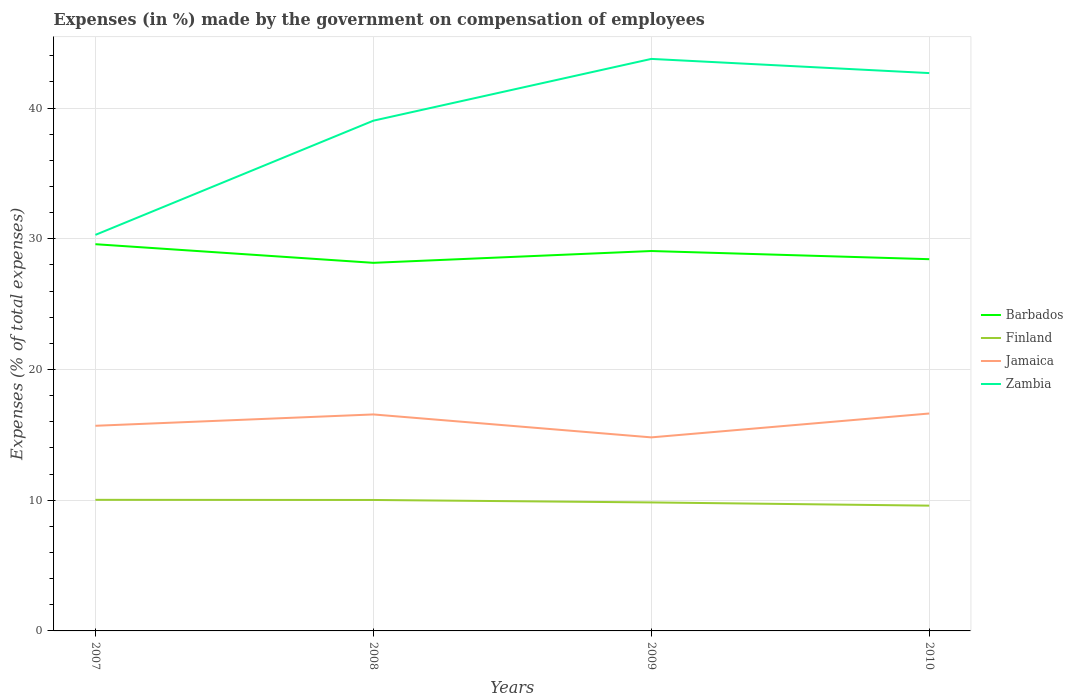Does the line corresponding to Barbados intersect with the line corresponding to Jamaica?
Make the answer very short. No. Is the number of lines equal to the number of legend labels?
Offer a terse response. Yes. Across all years, what is the maximum percentage of expenses made by the government on compensation of employees in Zambia?
Offer a terse response. 30.3. What is the total percentage of expenses made by the government on compensation of employees in Barbados in the graph?
Your answer should be very brief. -0.28. What is the difference between the highest and the second highest percentage of expenses made by the government on compensation of employees in Zambia?
Your answer should be compact. 13.46. What is the difference between the highest and the lowest percentage of expenses made by the government on compensation of employees in Finland?
Make the answer very short. 2. What is the difference between two consecutive major ticks on the Y-axis?
Provide a succinct answer. 10. Does the graph contain any zero values?
Make the answer very short. No. Where does the legend appear in the graph?
Offer a terse response. Center right. How many legend labels are there?
Ensure brevity in your answer.  4. What is the title of the graph?
Your answer should be compact. Expenses (in %) made by the government on compensation of employees. What is the label or title of the Y-axis?
Provide a short and direct response. Expenses (% of total expenses). What is the Expenses (% of total expenses) in Barbados in 2007?
Your answer should be very brief. 29.59. What is the Expenses (% of total expenses) of Finland in 2007?
Provide a short and direct response. 10.03. What is the Expenses (% of total expenses) in Jamaica in 2007?
Ensure brevity in your answer.  15.69. What is the Expenses (% of total expenses) of Zambia in 2007?
Your response must be concise. 30.3. What is the Expenses (% of total expenses) of Barbados in 2008?
Your response must be concise. 28.16. What is the Expenses (% of total expenses) in Finland in 2008?
Offer a terse response. 10.02. What is the Expenses (% of total expenses) in Jamaica in 2008?
Give a very brief answer. 16.56. What is the Expenses (% of total expenses) in Zambia in 2008?
Your answer should be very brief. 39.03. What is the Expenses (% of total expenses) of Barbados in 2009?
Your response must be concise. 29.06. What is the Expenses (% of total expenses) in Finland in 2009?
Provide a succinct answer. 9.83. What is the Expenses (% of total expenses) of Jamaica in 2009?
Offer a very short reply. 14.81. What is the Expenses (% of total expenses) of Zambia in 2009?
Offer a very short reply. 43.76. What is the Expenses (% of total expenses) of Barbados in 2010?
Ensure brevity in your answer.  28.44. What is the Expenses (% of total expenses) in Finland in 2010?
Provide a short and direct response. 9.58. What is the Expenses (% of total expenses) in Jamaica in 2010?
Offer a terse response. 16.63. What is the Expenses (% of total expenses) of Zambia in 2010?
Your response must be concise. 42.68. Across all years, what is the maximum Expenses (% of total expenses) in Barbados?
Keep it short and to the point. 29.59. Across all years, what is the maximum Expenses (% of total expenses) of Finland?
Give a very brief answer. 10.03. Across all years, what is the maximum Expenses (% of total expenses) in Jamaica?
Offer a terse response. 16.63. Across all years, what is the maximum Expenses (% of total expenses) in Zambia?
Give a very brief answer. 43.76. Across all years, what is the minimum Expenses (% of total expenses) in Barbados?
Your answer should be compact. 28.16. Across all years, what is the minimum Expenses (% of total expenses) in Finland?
Keep it short and to the point. 9.58. Across all years, what is the minimum Expenses (% of total expenses) of Jamaica?
Your answer should be compact. 14.81. Across all years, what is the minimum Expenses (% of total expenses) of Zambia?
Provide a short and direct response. 30.3. What is the total Expenses (% of total expenses) of Barbados in the graph?
Provide a succinct answer. 115.25. What is the total Expenses (% of total expenses) of Finland in the graph?
Ensure brevity in your answer.  39.46. What is the total Expenses (% of total expenses) of Jamaica in the graph?
Keep it short and to the point. 63.7. What is the total Expenses (% of total expenses) of Zambia in the graph?
Your response must be concise. 155.77. What is the difference between the Expenses (% of total expenses) in Barbados in 2007 and that in 2008?
Offer a very short reply. 1.43. What is the difference between the Expenses (% of total expenses) in Finland in 2007 and that in 2008?
Keep it short and to the point. 0.01. What is the difference between the Expenses (% of total expenses) in Jamaica in 2007 and that in 2008?
Offer a very short reply. -0.87. What is the difference between the Expenses (% of total expenses) of Zambia in 2007 and that in 2008?
Provide a succinct answer. -8.74. What is the difference between the Expenses (% of total expenses) of Barbados in 2007 and that in 2009?
Give a very brief answer. 0.52. What is the difference between the Expenses (% of total expenses) in Finland in 2007 and that in 2009?
Provide a succinct answer. 0.2. What is the difference between the Expenses (% of total expenses) in Jamaica in 2007 and that in 2009?
Your answer should be compact. 0.89. What is the difference between the Expenses (% of total expenses) in Zambia in 2007 and that in 2009?
Provide a succinct answer. -13.46. What is the difference between the Expenses (% of total expenses) in Barbados in 2007 and that in 2010?
Your answer should be compact. 1.15. What is the difference between the Expenses (% of total expenses) of Finland in 2007 and that in 2010?
Your response must be concise. 0.45. What is the difference between the Expenses (% of total expenses) in Jamaica in 2007 and that in 2010?
Your answer should be very brief. -0.94. What is the difference between the Expenses (% of total expenses) of Zambia in 2007 and that in 2010?
Give a very brief answer. -12.38. What is the difference between the Expenses (% of total expenses) of Barbados in 2008 and that in 2009?
Offer a terse response. -0.9. What is the difference between the Expenses (% of total expenses) in Finland in 2008 and that in 2009?
Give a very brief answer. 0.19. What is the difference between the Expenses (% of total expenses) of Jamaica in 2008 and that in 2009?
Offer a terse response. 1.75. What is the difference between the Expenses (% of total expenses) in Zambia in 2008 and that in 2009?
Your answer should be very brief. -4.73. What is the difference between the Expenses (% of total expenses) of Barbados in 2008 and that in 2010?
Your answer should be compact. -0.28. What is the difference between the Expenses (% of total expenses) in Finland in 2008 and that in 2010?
Provide a succinct answer. 0.43. What is the difference between the Expenses (% of total expenses) in Jamaica in 2008 and that in 2010?
Make the answer very short. -0.07. What is the difference between the Expenses (% of total expenses) in Zambia in 2008 and that in 2010?
Your answer should be compact. -3.64. What is the difference between the Expenses (% of total expenses) in Barbados in 2009 and that in 2010?
Ensure brevity in your answer.  0.63. What is the difference between the Expenses (% of total expenses) in Finland in 2009 and that in 2010?
Provide a succinct answer. 0.25. What is the difference between the Expenses (% of total expenses) of Jamaica in 2009 and that in 2010?
Offer a very short reply. -1.83. What is the difference between the Expenses (% of total expenses) of Zambia in 2009 and that in 2010?
Your answer should be compact. 1.08. What is the difference between the Expenses (% of total expenses) of Barbados in 2007 and the Expenses (% of total expenses) of Finland in 2008?
Ensure brevity in your answer.  19.57. What is the difference between the Expenses (% of total expenses) in Barbados in 2007 and the Expenses (% of total expenses) in Jamaica in 2008?
Give a very brief answer. 13.02. What is the difference between the Expenses (% of total expenses) in Barbados in 2007 and the Expenses (% of total expenses) in Zambia in 2008?
Your answer should be very brief. -9.45. What is the difference between the Expenses (% of total expenses) in Finland in 2007 and the Expenses (% of total expenses) in Jamaica in 2008?
Offer a very short reply. -6.53. What is the difference between the Expenses (% of total expenses) in Finland in 2007 and the Expenses (% of total expenses) in Zambia in 2008?
Provide a succinct answer. -29.01. What is the difference between the Expenses (% of total expenses) in Jamaica in 2007 and the Expenses (% of total expenses) in Zambia in 2008?
Make the answer very short. -23.34. What is the difference between the Expenses (% of total expenses) of Barbados in 2007 and the Expenses (% of total expenses) of Finland in 2009?
Offer a terse response. 19.75. What is the difference between the Expenses (% of total expenses) in Barbados in 2007 and the Expenses (% of total expenses) in Jamaica in 2009?
Provide a short and direct response. 14.78. What is the difference between the Expenses (% of total expenses) in Barbados in 2007 and the Expenses (% of total expenses) in Zambia in 2009?
Your answer should be very brief. -14.18. What is the difference between the Expenses (% of total expenses) of Finland in 2007 and the Expenses (% of total expenses) of Jamaica in 2009?
Offer a very short reply. -4.78. What is the difference between the Expenses (% of total expenses) in Finland in 2007 and the Expenses (% of total expenses) in Zambia in 2009?
Offer a terse response. -33.73. What is the difference between the Expenses (% of total expenses) in Jamaica in 2007 and the Expenses (% of total expenses) in Zambia in 2009?
Your response must be concise. -28.07. What is the difference between the Expenses (% of total expenses) of Barbados in 2007 and the Expenses (% of total expenses) of Finland in 2010?
Offer a very short reply. 20. What is the difference between the Expenses (% of total expenses) in Barbados in 2007 and the Expenses (% of total expenses) in Jamaica in 2010?
Ensure brevity in your answer.  12.95. What is the difference between the Expenses (% of total expenses) in Barbados in 2007 and the Expenses (% of total expenses) in Zambia in 2010?
Your response must be concise. -13.09. What is the difference between the Expenses (% of total expenses) of Finland in 2007 and the Expenses (% of total expenses) of Jamaica in 2010?
Your answer should be very brief. -6.6. What is the difference between the Expenses (% of total expenses) in Finland in 2007 and the Expenses (% of total expenses) in Zambia in 2010?
Provide a succinct answer. -32.65. What is the difference between the Expenses (% of total expenses) in Jamaica in 2007 and the Expenses (% of total expenses) in Zambia in 2010?
Your answer should be compact. -26.98. What is the difference between the Expenses (% of total expenses) of Barbados in 2008 and the Expenses (% of total expenses) of Finland in 2009?
Your answer should be compact. 18.33. What is the difference between the Expenses (% of total expenses) of Barbados in 2008 and the Expenses (% of total expenses) of Jamaica in 2009?
Offer a very short reply. 13.35. What is the difference between the Expenses (% of total expenses) in Barbados in 2008 and the Expenses (% of total expenses) in Zambia in 2009?
Provide a short and direct response. -15.6. What is the difference between the Expenses (% of total expenses) in Finland in 2008 and the Expenses (% of total expenses) in Jamaica in 2009?
Your answer should be compact. -4.79. What is the difference between the Expenses (% of total expenses) in Finland in 2008 and the Expenses (% of total expenses) in Zambia in 2009?
Your answer should be very brief. -33.74. What is the difference between the Expenses (% of total expenses) in Jamaica in 2008 and the Expenses (% of total expenses) in Zambia in 2009?
Keep it short and to the point. -27.2. What is the difference between the Expenses (% of total expenses) of Barbados in 2008 and the Expenses (% of total expenses) of Finland in 2010?
Offer a very short reply. 18.58. What is the difference between the Expenses (% of total expenses) of Barbados in 2008 and the Expenses (% of total expenses) of Jamaica in 2010?
Keep it short and to the point. 11.53. What is the difference between the Expenses (% of total expenses) in Barbados in 2008 and the Expenses (% of total expenses) in Zambia in 2010?
Ensure brevity in your answer.  -14.52. What is the difference between the Expenses (% of total expenses) of Finland in 2008 and the Expenses (% of total expenses) of Jamaica in 2010?
Offer a terse response. -6.62. What is the difference between the Expenses (% of total expenses) in Finland in 2008 and the Expenses (% of total expenses) in Zambia in 2010?
Make the answer very short. -32.66. What is the difference between the Expenses (% of total expenses) of Jamaica in 2008 and the Expenses (% of total expenses) of Zambia in 2010?
Your answer should be very brief. -26.11. What is the difference between the Expenses (% of total expenses) in Barbados in 2009 and the Expenses (% of total expenses) in Finland in 2010?
Keep it short and to the point. 19.48. What is the difference between the Expenses (% of total expenses) in Barbados in 2009 and the Expenses (% of total expenses) in Jamaica in 2010?
Provide a succinct answer. 12.43. What is the difference between the Expenses (% of total expenses) of Barbados in 2009 and the Expenses (% of total expenses) of Zambia in 2010?
Provide a succinct answer. -13.61. What is the difference between the Expenses (% of total expenses) in Finland in 2009 and the Expenses (% of total expenses) in Jamaica in 2010?
Your answer should be compact. -6.8. What is the difference between the Expenses (% of total expenses) of Finland in 2009 and the Expenses (% of total expenses) of Zambia in 2010?
Keep it short and to the point. -32.85. What is the difference between the Expenses (% of total expenses) of Jamaica in 2009 and the Expenses (% of total expenses) of Zambia in 2010?
Your answer should be very brief. -27.87. What is the average Expenses (% of total expenses) in Barbados per year?
Offer a very short reply. 28.81. What is the average Expenses (% of total expenses) of Finland per year?
Give a very brief answer. 9.87. What is the average Expenses (% of total expenses) in Jamaica per year?
Make the answer very short. 15.92. What is the average Expenses (% of total expenses) in Zambia per year?
Keep it short and to the point. 38.94. In the year 2007, what is the difference between the Expenses (% of total expenses) in Barbados and Expenses (% of total expenses) in Finland?
Your answer should be compact. 19.56. In the year 2007, what is the difference between the Expenses (% of total expenses) of Barbados and Expenses (% of total expenses) of Jamaica?
Your response must be concise. 13.89. In the year 2007, what is the difference between the Expenses (% of total expenses) in Barbados and Expenses (% of total expenses) in Zambia?
Your response must be concise. -0.71. In the year 2007, what is the difference between the Expenses (% of total expenses) in Finland and Expenses (% of total expenses) in Jamaica?
Make the answer very short. -5.66. In the year 2007, what is the difference between the Expenses (% of total expenses) of Finland and Expenses (% of total expenses) of Zambia?
Your response must be concise. -20.27. In the year 2007, what is the difference between the Expenses (% of total expenses) in Jamaica and Expenses (% of total expenses) in Zambia?
Offer a terse response. -14.6. In the year 2008, what is the difference between the Expenses (% of total expenses) in Barbados and Expenses (% of total expenses) in Finland?
Keep it short and to the point. 18.14. In the year 2008, what is the difference between the Expenses (% of total expenses) of Barbados and Expenses (% of total expenses) of Jamaica?
Your response must be concise. 11.6. In the year 2008, what is the difference between the Expenses (% of total expenses) in Barbados and Expenses (% of total expenses) in Zambia?
Offer a very short reply. -10.87. In the year 2008, what is the difference between the Expenses (% of total expenses) in Finland and Expenses (% of total expenses) in Jamaica?
Provide a succinct answer. -6.54. In the year 2008, what is the difference between the Expenses (% of total expenses) in Finland and Expenses (% of total expenses) in Zambia?
Provide a succinct answer. -29.02. In the year 2008, what is the difference between the Expenses (% of total expenses) in Jamaica and Expenses (% of total expenses) in Zambia?
Ensure brevity in your answer.  -22.47. In the year 2009, what is the difference between the Expenses (% of total expenses) in Barbados and Expenses (% of total expenses) in Finland?
Your response must be concise. 19.23. In the year 2009, what is the difference between the Expenses (% of total expenses) of Barbados and Expenses (% of total expenses) of Jamaica?
Offer a terse response. 14.26. In the year 2009, what is the difference between the Expenses (% of total expenses) in Barbados and Expenses (% of total expenses) in Zambia?
Your answer should be very brief. -14.7. In the year 2009, what is the difference between the Expenses (% of total expenses) in Finland and Expenses (% of total expenses) in Jamaica?
Provide a short and direct response. -4.98. In the year 2009, what is the difference between the Expenses (% of total expenses) in Finland and Expenses (% of total expenses) in Zambia?
Your answer should be compact. -33.93. In the year 2009, what is the difference between the Expenses (% of total expenses) of Jamaica and Expenses (% of total expenses) of Zambia?
Provide a succinct answer. -28.95. In the year 2010, what is the difference between the Expenses (% of total expenses) in Barbados and Expenses (% of total expenses) in Finland?
Offer a terse response. 18.85. In the year 2010, what is the difference between the Expenses (% of total expenses) in Barbados and Expenses (% of total expenses) in Jamaica?
Your answer should be compact. 11.8. In the year 2010, what is the difference between the Expenses (% of total expenses) in Barbados and Expenses (% of total expenses) in Zambia?
Offer a very short reply. -14.24. In the year 2010, what is the difference between the Expenses (% of total expenses) of Finland and Expenses (% of total expenses) of Jamaica?
Provide a short and direct response. -7.05. In the year 2010, what is the difference between the Expenses (% of total expenses) of Finland and Expenses (% of total expenses) of Zambia?
Make the answer very short. -33.09. In the year 2010, what is the difference between the Expenses (% of total expenses) of Jamaica and Expenses (% of total expenses) of Zambia?
Your answer should be compact. -26.04. What is the ratio of the Expenses (% of total expenses) in Barbados in 2007 to that in 2008?
Provide a succinct answer. 1.05. What is the ratio of the Expenses (% of total expenses) of Jamaica in 2007 to that in 2008?
Provide a succinct answer. 0.95. What is the ratio of the Expenses (% of total expenses) in Zambia in 2007 to that in 2008?
Keep it short and to the point. 0.78. What is the ratio of the Expenses (% of total expenses) of Barbados in 2007 to that in 2009?
Make the answer very short. 1.02. What is the ratio of the Expenses (% of total expenses) of Finland in 2007 to that in 2009?
Offer a very short reply. 1.02. What is the ratio of the Expenses (% of total expenses) in Jamaica in 2007 to that in 2009?
Ensure brevity in your answer.  1.06. What is the ratio of the Expenses (% of total expenses) in Zambia in 2007 to that in 2009?
Make the answer very short. 0.69. What is the ratio of the Expenses (% of total expenses) of Barbados in 2007 to that in 2010?
Provide a succinct answer. 1.04. What is the ratio of the Expenses (% of total expenses) in Finland in 2007 to that in 2010?
Your response must be concise. 1.05. What is the ratio of the Expenses (% of total expenses) in Jamaica in 2007 to that in 2010?
Provide a short and direct response. 0.94. What is the ratio of the Expenses (% of total expenses) of Zambia in 2007 to that in 2010?
Keep it short and to the point. 0.71. What is the ratio of the Expenses (% of total expenses) of Barbados in 2008 to that in 2009?
Offer a very short reply. 0.97. What is the ratio of the Expenses (% of total expenses) in Finland in 2008 to that in 2009?
Ensure brevity in your answer.  1.02. What is the ratio of the Expenses (% of total expenses) of Jamaica in 2008 to that in 2009?
Ensure brevity in your answer.  1.12. What is the ratio of the Expenses (% of total expenses) of Zambia in 2008 to that in 2009?
Offer a terse response. 0.89. What is the ratio of the Expenses (% of total expenses) of Barbados in 2008 to that in 2010?
Make the answer very short. 0.99. What is the ratio of the Expenses (% of total expenses) in Finland in 2008 to that in 2010?
Offer a very short reply. 1.05. What is the ratio of the Expenses (% of total expenses) of Jamaica in 2008 to that in 2010?
Make the answer very short. 1. What is the ratio of the Expenses (% of total expenses) of Zambia in 2008 to that in 2010?
Offer a terse response. 0.91. What is the ratio of the Expenses (% of total expenses) of Barbados in 2009 to that in 2010?
Provide a succinct answer. 1.02. What is the ratio of the Expenses (% of total expenses) of Finland in 2009 to that in 2010?
Provide a succinct answer. 1.03. What is the ratio of the Expenses (% of total expenses) in Jamaica in 2009 to that in 2010?
Offer a very short reply. 0.89. What is the ratio of the Expenses (% of total expenses) of Zambia in 2009 to that in 2010?
Offer a very short reply. 1.03. What is the difference between the highest and the second highest Expenses (% of total expenses) of Barbados?
Offer a terse response. 0.52. What is the difference between the highest and the second highest Expenses (% of total expenses) of Finland?
Give a very brief answer. 0.01. What is the difference between the highest and the second highest Expenses (% of total expenses) of Jamaica?
Your answer should be very brief. 0.07. What is the difference between the highest and the second highest Expenses (% of total expenses) of Zambia?
Your answer should be very brief. 1.08. What is the difference between the highest and the lowest Expenses (% of total expenses) of Barbados?
Ensure brevity in your answer.  1.43. What is the difference between the highest and the lowest Expenses (% of total expenses) of Finland?
Provide a short and direct response. 0.45. What is the difference between the highest and the lowest Expenses (% of total expenses) in Jamaica?
Ensure brevity in your answer.  1.83. What is the difference between the highest and the lowest Expenses (% of total expenses) in Zambia?
Your answer should be compact. 13.46. 